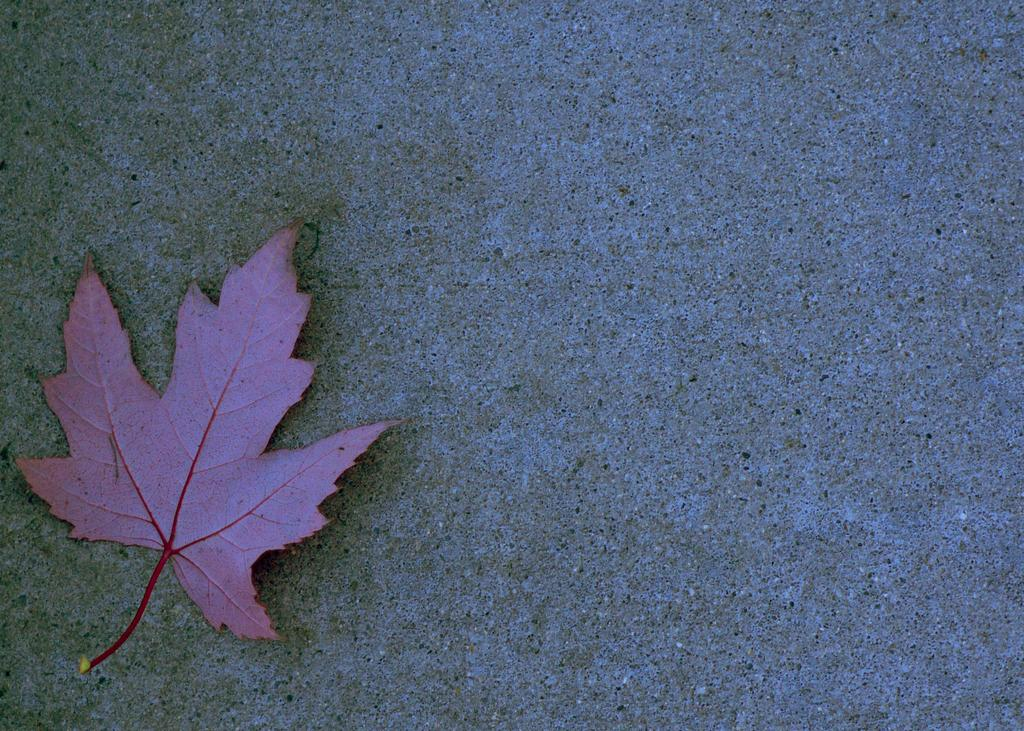What is the main subject of the image? The main subject of the image is a leaf. Can you describe the color of the leaf? The leaf is in pink or purple color. What can be seen in the background of the image? There is a wall or pavement in the background of the image. Is there any attempt to escape from the quicksand in the image? There is no quicksand or any attempt to escape from it in the image, as it only features a leaf in pink or purple color and a wall or pavement in the background. 